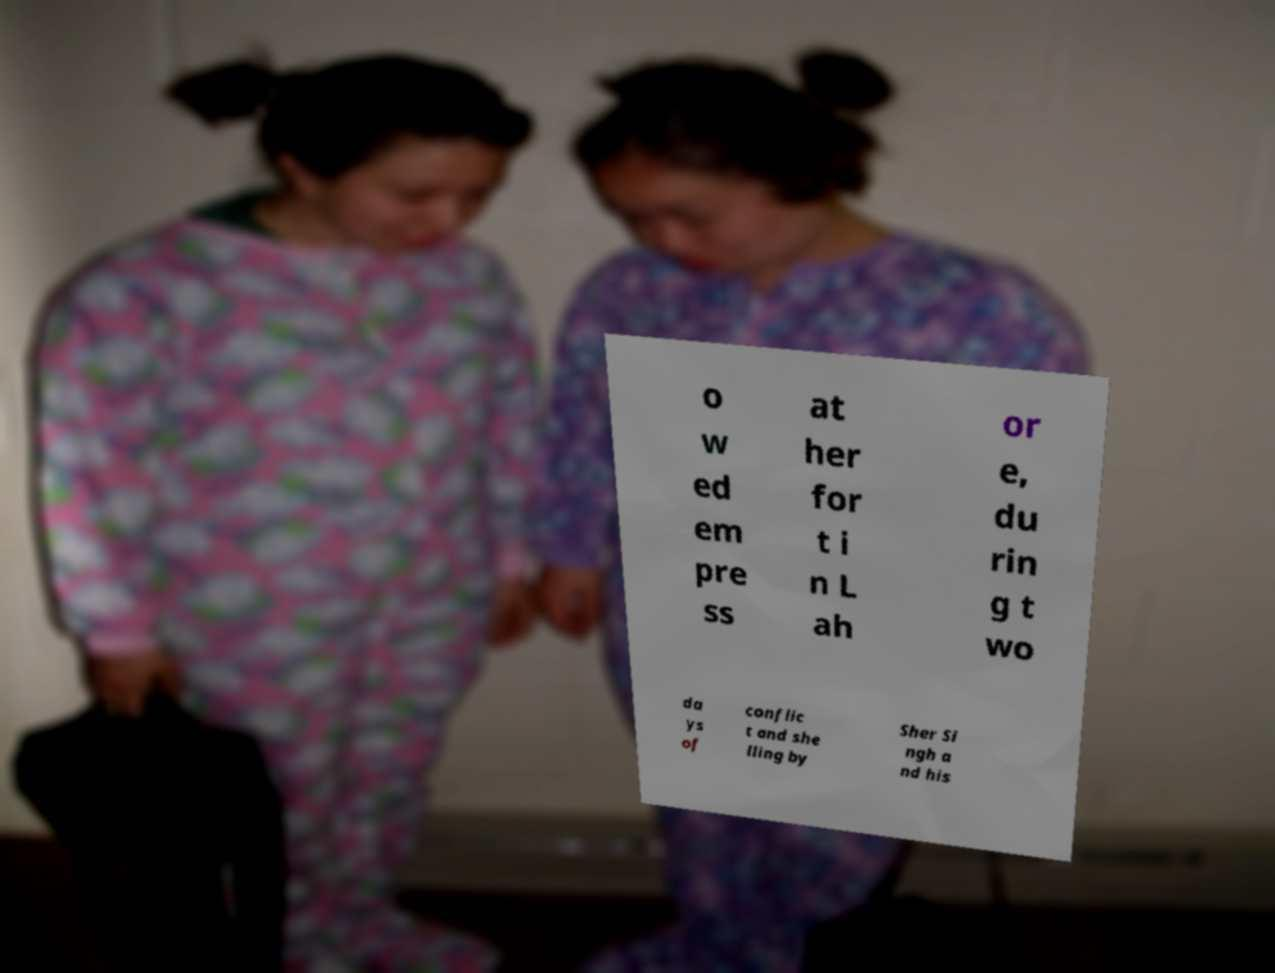Can you accurately transcribe the text from the provided image for me? o w ed em pre ss at her for t i n L ah or e, du rin g t wo da ys of conflic t and she lling by Sher Si ngh a nd his 